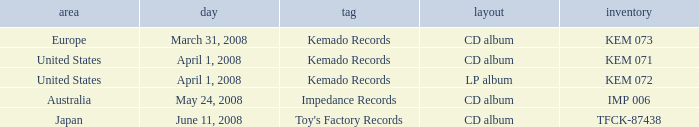Which Format has a Label of toy's factory records? CD album. 